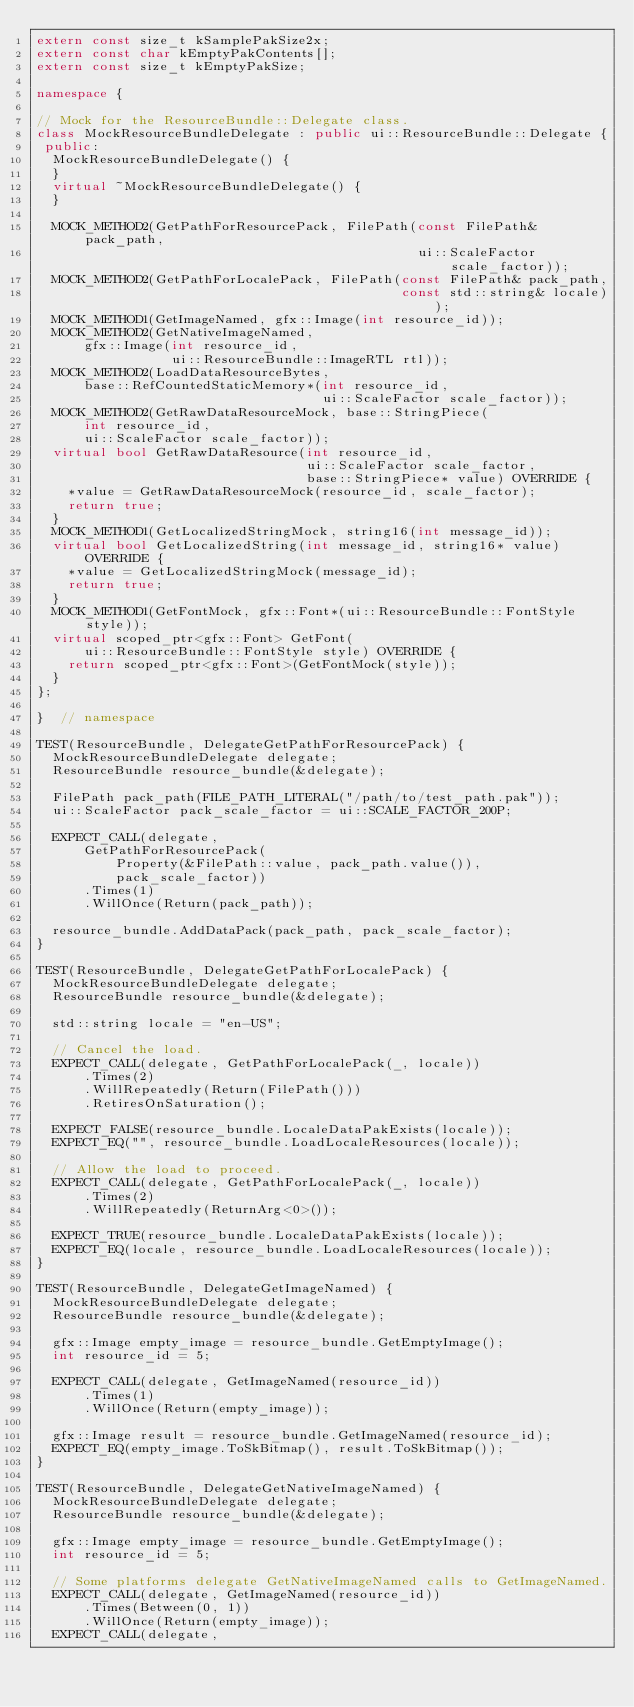<code> <loc_0><loc_0><loc_500><loc_500><_C++_>extern const size_t kSamplePakSize2x;
extern const char kEmptyPakContents[];
extern const size_t kEmptyPakSize;

namespace {

// Mock for the ResourceBundle::Delegate class.
class MockResourceBundleDelegate : public ui::ResourceBundle::Delegate {
 public:
  MockResourceBundleDelegate() {
  }
  virtual ~MockResourceBundleDelegate() {
  }

  MOCK_METHOD2(GetPathForResourcePack, FilePath(const FilePath& pack_path,
                                                ui::ScaleFactor scale_factor));
  MOCK_METHOD2(GetPathForLocalePack, FilePath(const FilePath& pack_path,
                                              const std::string& locale));
  MOCK_METHOD1(GetImageNamed, gfx::Image(int resource_id));
  MOCK_METHOD2(GetNativeImageNamed,
      gfx::Image(int resource_id,
                 ui::ResourceBundle::ImageRTL rtl));
  MOCK_METHOD2(LoadDataResourceBytes,
      base::RefCountedStaticMemory*(int resource_id,
                                    ui::ScaleFactor scale_factor));
  MOCK_METHOD2(GetRawDataResourceMock, base::StringPiece(
      int resource_id,
      ui::ScaleFactor scale_factor));
  virtual bool GetRawDataResource(int resource_id,
                                  ui::ScaleFactor scale_factor,
                                  base::StringPiece* value) OVERRIDE {
    *value = GetRawDataResourceMock(resource_id, scale_factor);
    return true;
  }
  MOCK_METHOD1(GetLocalizedStringMock, string16(int message_id));
  virtual bool GetLocalizedString(int message_id, string16* value) OVERRIDE {
    *value = GetLocalizedStringMock(message_id);
    return true;
  }
  MOCK_METHOD1(GetFontMock, gfx::Font*(ui::ResourceBundle::FontStyle style));
  virtual scoped_ptr<gfx::Font> GetFont(
      ui::ResourceBundle::FontStyle style) OVERRIDE {
    return scoped_ptr<gfx::Font>(GetFontMock(style));
  }
};

}  // namespace

TEST(ResourceBundle, DelegateGetPathForResourcePack) {
  MockResourceBundleDelegate delegate;
  ResourceBundle resource_bundle(&delegate);

  FilePath pack_path(FILE_PATH_LITERAL("/path/to/test_path.pak"));
  ui::ScaleFactor pack_scale_factor = ui::SCALE_FACTOR_200P;

  EXPECT_CALL(delegate,
      GetPathForResourcePack(
          Property(&FilePath::value, pack_path.value()),
          pack_scale_factor))
      .Times(1)
      .WillOnce(Return(pack_path));

  resource_bundle.AddDataPack(pack_path, pack_scale_factor);
}

TEST(ResourceBundle, DelegateGetPathForLocalePack) {
  MockResourceBundleDelegate delegate;
  ResourceBundle resource_bundle(&delegate);

  std::string locale = "en-US";

  // Cancel the load.
  EXPECT_CALL(delegate, GetPathForLocalePack(_, locale))
      .Times(2)
      .WillRepeatedly(Return(FilePath()))
      .RetiresOnSaturation();

  EXPECT_FALSE(resource_bundle.LocaleDataPakExists(locale));
  EXPECT_EQ("", resource_bundle.LoadLocaleResources(locale));

  // Allow the load to proceed.
  EXPECT_CALL(delegate, GetPathForLocalePack(_, locale))
      .Times(2)
      .WillRepeatedly(ReturnArg<0>());

  EXPECT_TRUE(resource_bundle.LocaleDataPakExists(locale));
  EXPECT_EQ(locale, resource_bundle.LoadLocaleResources(locale));
}

TEST(ResourceBundle, DelegateGetImageNamed) {
  MockResourceBundleDelegate delegate;
  ResourceBundle resource_bundle(&delegate);

  gfx::Image empty_image = resource_bundle.GetEmptyImage();
  int resource_id = 5;

  EXPECT_CALL(delegate, GetImageNamed(resource_id))
      .Times(1)
      .WillOnce(Return(empty_image));

  gfx::Image result = resource_bundle.GetImageNamed(resource_id);
  EXPECT_EQ(empty_image.ToSkBitmap(), result.ToSkBitmap());
}

TEST(ResourceBundle, DelegateGetNativeImageNamed) {
  MockResourceBundleDelegate delegate;
  ResourceBundle resource_bundle(&delegate);

  gfx::Image empty_image = resource_bundle.GetEmptyImage();
  int resource_id = 5;

  // Some platforms delegate GetNativeImageNamed calls to GetImageNamed.
  EXPECT_CALL(delegate, GetImageNamed(resource_id))
      .Times(Between(0, 1))
      .WillOnce(Return(empty_image));
  EXPECT_CALL(delegate,</code> 